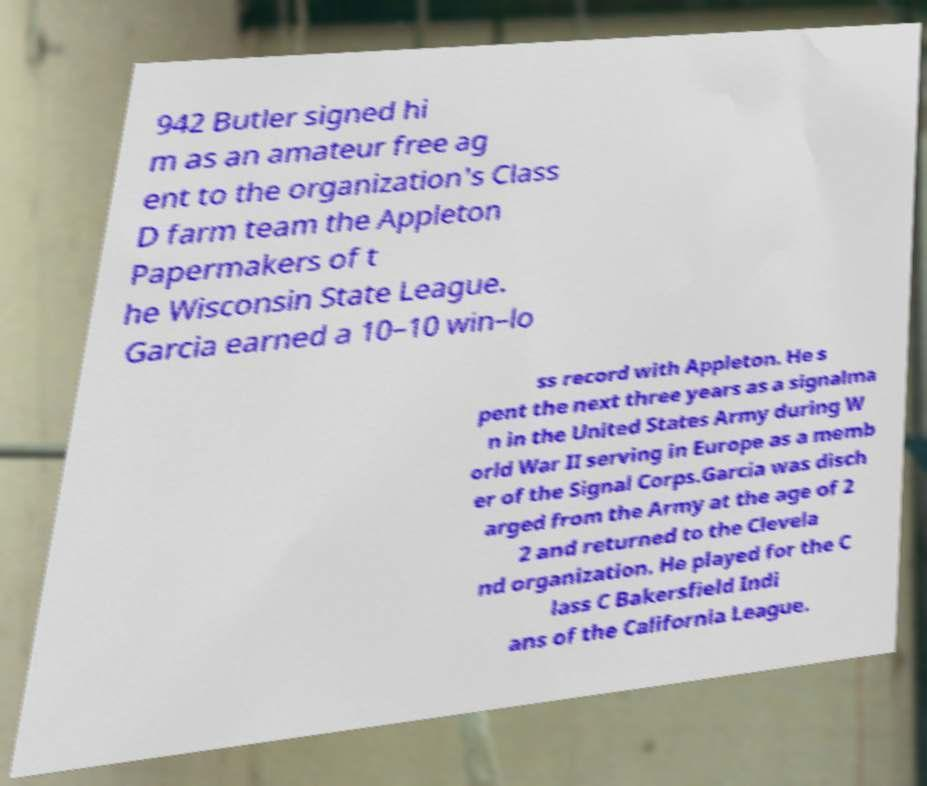Could you assist in decoding the text presented in this image and type it out clearly? 942 Butler signed hi m as an amateur free ag ent to the organization's Class D farm team the Appleton Papermakers of t he Wisconsin State League. Garcia earned a 10–10 win–lo ss record with Appleton. He s pent the next three years as a signalma n in the United States Army during W orld War II serving in Europe as a memb er of the Signal Corps.Garcia was disch arged from the Army at the age of 2 2 and returned to the Clevela nd organization. He played for the C lass C Bakersfield Indi ans of the California League. 